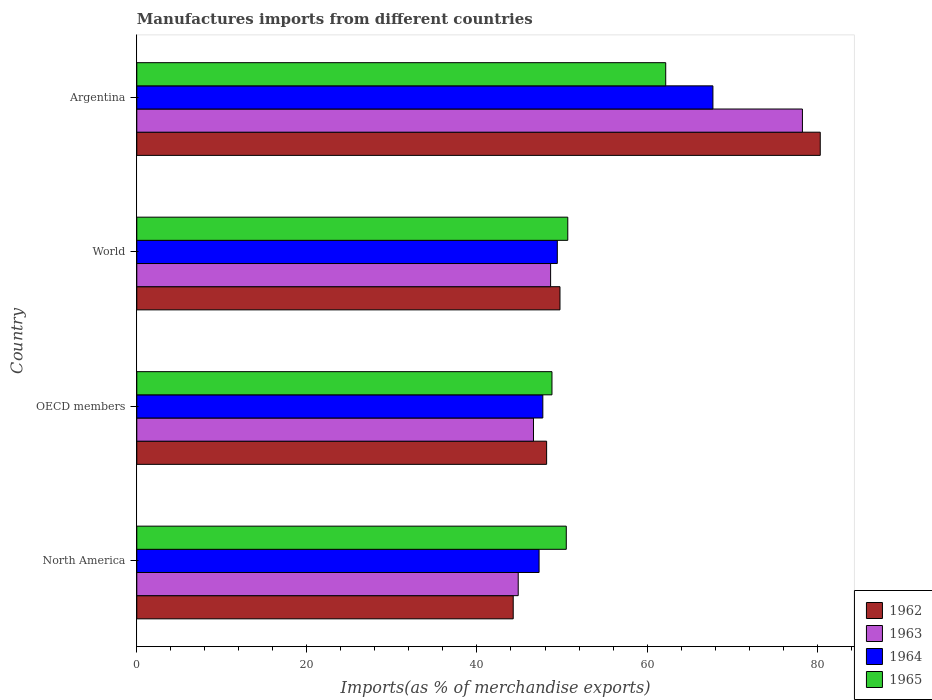How many groups of bars are there?
Provide a succinct answer. 4. Are the number of bars per tick equal to the number of legend labels?
Your answer should be very brief. Yes. Are the number of bars on each tick of the Y-axis equal?
Provide a succinct answer. Yes. What is the label of the 1st group of bars from the top?
Offer a very short reply. Argentina. In how many cases, is the number of bars for a given country not equal to the number of legend labels?
Your answer should be very brief. 0. What is the percentage of imports to different countries in 1964 in OECD members?
Give a very brief answer. 47.75. Across all countries, what is the maximum percentage of imports to different countries in 1963?
Your answer should be compact. 78.27. Across all countries, what is the minimum percentage of imports to different countries in 1963?
Ensure brevity in your answer.  44.85. In which country was the percentage of imports to different countries in 1962 maximum?
Offer a terse response. Argentina. What is the total percentage of imports to different countries in 1964 in the graph?
Keep it short and to the point. 212.24. What is the difference between the percentage of imports to different countries in 1962 in North America and that in OECD members?
Ensure brevity in your answer.  -3.93. What is the difference between the percentage of imports to different countries in 1963 in North America and the percentage of imports to different countries in 1964 in World?
Your response must be concise. -4.6. What is the average percentage of imports to different countries in 1962 per country?
Offer a very short reply. 55.65. What is the difference between the percentage of imports to different countries in 1964 and percentage of imports to different countries in 1965 in Argentina?
Ensure brevity in your answer.  5.55. What is the ratio of the percentage of imports to different countries in 1964 in North America to that in World?
Make the answer very short. 0.96. Is the percentage of imports to different countries in 1964 in North America less than that in World?
Provide a succinct answer. Yes. Is the difference between the percentage of imports to different countries in 1964 in OECD members and World greater than the difference between the percentage of imports to different countries in 1965 in OECD members and World?
Offer a very short reply. Yes. What is the difference between the highest and the second highest percentage of imports to different countries in 1965?
Keep it short and to the point. 11.52. What is the difference between the highest and the lowest percentage of imports to different countries in 1964?
Your response must be concise. 20.44. In how many countries, is the percentage of imports to different countries in 1965 greater than the average percentage of imports to different countries in 1965 taken over all countries?
Offer a very short reply. 1. Is the sum of the percentage of imports to different countries in 1963 in North America and World greater than the maximum percentage of imports to different countries in 1965 across all countries?
Offer a terse response. Yes. What does the 3rd bar from the bottom in Argentina represents?
Your answer should be very brief. 1964. How many bars are there?
Offer a very short reply. 16. How many countries are there in the graph?
Your answer should be compact. 4. What is the difference between two consecutive major ticks on the X-axis?
Your answer should be compact. 20. How are the legend labels stacked?
Offer a terse response. Vertical. What is the title of the graph?
Offer a terse response. Manufactures imports from different countries. What is the label or title of the X-axis?
Give a very brief answer. Imports(as % of merchandise exports). What is the label or title of the Y-axis?
Your response must be concise. Country. What is the Imports(as % of merchandise exports) in 1962 in North America?
Make the answer very short. 44.26. What is the Imports(as % of merchandise exports) of 1963 in North America?
Your answer should be compact. 44.85. What is the Imports(as % of merchandise exports) in 1964 in North America?
Make the answer very short. 47.3. What is the Imports(as % of merchandise exports) in 1965 in North America?
Your response must be concise. 50.5. What is the Imports(as % of merchandise exports) in 1962 in OECD members?
Your answer should be very brief. 48.19. What is the Imports(as % of merchandise exports) of 1963 in OECD members?
Offer a terse response. 46.65. What is the Imports(as % of merchandise exports) in 1964 in OECD members?
Ensure brevity in your answer.  47.75. What is the Imports(as % of merchandise exports) of 1965 in OECD members?
Offer a terse response. 48.82. What is the Imports(as % of merchandise exports) in 1962 in World?
Provide a short and direct response. 49.76. What is the Imports(as % of merchandise exports) in 1963 in World?
Give a very brief answer. 48.66. What is the Imports(as % of merchandise exports) of 1964 in World?
Your response must be concise. 49.45. What is the Imports(as % of merchandise exports) of 1965 in World?
Your answer should be very brief. 50.68. What is the Imports(as % of merchandise exports) of 1962 in Argentina?
Your answer should be very brief. 80.37. What is the Imports(as % of merchandise exports) in 1963 in Argentina?
Provide a succinct answer. 78.27. What is the Imports(as % of merchandise exports) of 1964 in Argentina?
Make the answer very short. 67.75. What is the Imports(as % of merchandise exports) of 1965 in Argentina?
Provide a short and direct response. 62.19. Across all countries, what is the maximum Imports(as % of merchandise exports) in 1962?
Provide a succinct answer. 80.37. Across all countries, what is the maximum Imports(as % of merchandise exports) in 1963?
Keep it short and to the point. 78.27. Across all countries, what is the maximum Imports(as % of merchandise exports) of 1964?
Provide a short and direct response. 67.75. Across all countries, what is the maximum Imports(as % of merchandise exports) in 1965?
Your answer should be compact. 62.19. Across all countries, what is the minimum Imports(as % of merchandise exports) in 1962?
Offer a terse response. 44.26. Across all countries, what is the minimum Imports(as % of merchandise exports) of 1963?
Offer a terse response. 44.85. Across all countries, what is the minimum Imports(as % of merchandise exports) of 1964?
Keep it short and to the point. 47.3. Across all countries, what is the minimum Imports(as % of merchandise exports) of 1965?
Your response must be concise. 48.82. What is the total Imports(as % of merchandise exports) in 1962 in the graph?
Provide a succinct answer. 222.58. What is the total Imports(as % of merchandise exports) of 1963 in the graph?
Ensure brevity in your answer.  218.43. What is the total Imports(as % of merchandise exports) of 1964 in the graph?
Give a very brief answer. 212.24. What is the total Imports(as % of merchandise exports) in 1965 in the graph?
Your answer should be compact. 212.2. What is the difference between the Imports(as % of merchandise exports) of 1962 in North America and that in OECD members?
Make the answer very short. -3.93. What is the difference between the Imports(as % of merchandise exports) of 1963 in North America and that in OECD members?
Provide a short and direct response. -1.8. What is the difference between the Imports(as % of merchandise exports) in 1964 in North America and that in OECD members?
Give a very brief answer. -0.44. What is the difference between the Imports(as % of merchandise exports) in 1965 in North America and that in OECD members?
Make the answer very short. 1.68. What is the difference between the Imports(as % of merchandise exports) of 1962 in North America and that in World?
Offer a terse response. -5.5. What is the difference between the Imports(as % of merchandise exports) in 1963 in North America and that in World?
Your answer should be very brief. -3.81. What is the difference between the Imports(as % of merchandise exports) in 1964 in North America and that in World?
Your answer should be very brief. -2.14. What is the difference between the Imports(as % of merchandise exports) in 1965 in North America and that in World?
Give a very brief answer. -0.18. What is the difference between the Imports(as % of merchandise exports) of 1962 in North America and that in Argentina?
Ensure brevity in your answer.  -36.1. What is the difference between the Imports(as % of merchandise exports) in 1963 in North America and that in Argentina?
Give a very brief answer. -33.42. What is the difference between the Imports(as % of merchandise exports) in 1964 in North America and that in Argentina?
Your response must be concise. -20.44. What is the difference between the Imports(as % of merchandise exports) in 1965 in North America and that in Argentina?
Give a very brief answer. -11.69. What is the difference between the Imports(as % of merchandise exports) of 1962 in OECD members and that in World?
Your answer should be very brief. -1.57. What is the difference between the Imports(as % of merchandise exports) in 1963 in OECD members and that in World?
Give a very brief answer. -2.01. What is the difference between the Imports(as % of merchandise exports) of 1964 in OECD members and that in World?
Your response must be concise. -1.7. What is the difference between the Imports(as % of merchandise exports) of 1965 in OECD members and that in World?
Provide a short and direct response. -1.86. What is the difference between the Imports(as % of merchandise exports) of 1962 in OECD members and that in Argentina?
Your response must be concise. -32.17. What is the difference between the Imports(as % of merchandise exports) in 1963 in OECD members and that in Argentina?
Your response must be concise. -31.62. What is the difference between the Imports(as % of merchandise exports) in 1964 in OECD members and that in Argentina?
Make the answer very short. -20. What is the difference between the Imports(as % of merchandise exports) of 1965 in OECD members and that in Argentina?
Provide a succinct answer. -13.38. What is the difference between the Imports(as % of merchandise exports) in 1962 in World and that in Argentina?
Offer a very short reply. -30.61. What is the difference between the Imports(as % of merchandise exports) in 1963 in World and that in Argentina?
Your answer should be very brief. -29.61. What is the difference between the Imports(as % of merchandise exports) of 1964 in World and that in Argentina?
Provide a short and direct response. -18.3. What is the difference between the Imports(as % of merchandise exports) of 1965 in World and that in Argentina?
Provide a short and direct response. -11.52. What is the difference between the Imports(as % of merchandise exports) of 1962 in North America and the Imports(as % of merchandise exports) of 1963 in OECD members?
Your answer should be very brief. -2.38. What is the difference between the Imports(as % of merchandise exports) in 1962 in North America and the Imports(as % of merchandise exports) in 1964 in OECD members?
Offer a terse response. -3.48. What is the difference between the Imports(as % of merchandise exports) in 1962 in North America and the Imports(as % of merchandise exports) in 1965 in OECD members?
Your answer should be very brief. -4.56. What is the difference between the Imports(as % of merchandise exports) in 1963 in North America and the Imports(as % of merchandise exports) in 1964 in OECD members?
Offer a very short reply. -2.89. What is the difference between the Imports(as % of merchandise exports) in 1963 in North America and the Imports(as % of merchandise exports) in 1965 in OECD members?
Provide a succinct answer. -3.97. What is the difference between the Imports(as % of merchandise exports) of 1964 in North America and the Imports(as % of merchandise exports) of 1965 in OECD members?
Offer a very short reply. -1.52. What is the difference between the Imports(as % of merchandise exports) of 1962 in North America and the Imports(as % of merchandise exports) of 1963 in World?
Offer a terse response. -4.4. What is the difference between the Imports(as % of merchandise exports) of 1962 in North America and the Imports(as % of merchandise exports) of 1964 in World?
Make the answer very short. -5.19. What is the difference between the Imports(as % of merchandise exports) of 1962 in North America and the Imports(as % of merchandise exports) of 1965 in World?
Offer a very short reply. -6.42. What is the difference between the Imports(as % of merchandise exports) in 1963 in North America and the Imports(as % of merchandise exports) in 1964 in World?
Provide a short and direct response. -4.6. What is the difference between the Imports(as % of merchandise exports) in 1963 in North America and the Imports(as % of merchandise exports) in 1965 in World?
Your answer should be very brief. -5.83. What is the difference between the Imports(as % of merchandise exports) of 1964 in North America and the Imports(as % of merchandise exports) of 1965 in World?
Provide a short and direct response. -3.37. What is the difference between the Imports(as % of merchandise exports) of 1962 in North America and the Imports(as % of merchandise exports) of 1963 in Argentina?
Your response must be concise. -34.01. What is the difference between the Imports(as % of merchandise exports) of 1962 in North America and the Imports(as % of merchandise exports) of 1964 in Argentina?
Your response must be concise. -23.48. What is the difference between the Imports(as % of merchandise exports) in 1962 in North America and the Imports(as % of merchandise exports) in 1965 in Argentina?
Provide a succinct answer. -17.93. What is the difference between the Imports(as % of merchandise exports) in 1963 in North America and the Imports(as % of merchandise exports) in 1964 in Argentina?
Your answer should be compact. -22.89. What is the difference between the Imports(as % of merchandise exports) in 1963 in North America and the Imports(as % of merchandise exports) in 1965 in Argentina?
Your answer should be very brief. -17.34. What is the difference between the Imports(as % of merchandise exports) of 1964 in North America and the Imports(as % of merchandise exports) of 1965 in Argentina?
Your response must be concise. -14.89. What is the difference between the Imports(as % of merchandise exports) of 1962 in OECD members and the Imports(as % of merchandise exports) of 1963 in World?
Offer a terse response. -0.47. What is the difference between the Imports(as % of merchandise exports) of 1962 in OECD members and the Imports(as % of merchandise exports) of 1964 in World?
Provide a short and direct response. -1.26. What is the difference between the Imports(as % of merchandise exports) of 1962 in OECD members and the Imports(as % of merchandise exports) of 1965 in World?
Provide a succinct answer. -2.49. What is the difference between the Imports(as % of merchandise exports) of 1963 in OECD members and the Imports(as % of merchandise exports) of 1964 in World?
Provide a short and direct response. -2.8. What is the difference between the Imports(as % of merchandise exports) in 1963 in OECD members and the Imports(as % of merchandise exports) in 1965 in World?
Make the answer very short. -4.03. What is the difference between the Imports(as % of merchandise exports) in 1964 in OECD members and the Imports(as % of merchandise exports) in 1965 in World?
Offer a terse response. -2.93. What is the difference between the Imports(as % of merchandise exports) of 1962 in OECD members and the Imports(as % of merchandise exports) of 1963 in Argentina?
Ensure brevity in your answer.  -30.08. What is the difference between the Imports(as % of merchandise exports) in 1962 in OECD members and the Imports(as % of merchandise exports) in 1964 in Argentina?
Provide a short and direct response. -19.55. What is the difference between the Imports(as % of merchandise exports) in 1962 in OECD members and the Imports(as % of merchandise exports) in 1965 in Argentina?
Your answer should be very brief. -14. What is the difference between the Imports(as % of merchandise exports) of 1963 in OECD members and the Imports(as % of merchandise exports) of 1964 in Argentina?
Provide a succinct answer. -21.1. What is the difference between the Imports(as % of merchandise exports) of 1963 in OECD members and the Imports(as % of merchandise exports) of 1965 in Argentina?
Offer a very short reply. -15.55. What is the difference between the Imports(as % of merchandise exports) of 1964 in OECD members and the Imports(as % of merchandise exports) of 1965 in Argentina?
Your answer should be compact. -14.45. What is the difference between the Imports(as % of merchandise exports) in 1962 in World and the Imports(as % of merchandise exports) in 1963 in Argentina?
Your answer should be very brief. -28.51. What is the difference between the Imports(as % of merchandise exports) of 1962 in World and the Imports(as % of merchandise exports) of 1964 in Argentina?
Offer a terse response. -17.98. What is the difference between the Imports(as % of merchandise exports) of 1962 in World and the Imports(as % of merchandise exports) of 1965 in Argentina?
Provide a short and direct response. -12.43. What is the difference between the Imports(as % of merchandise exports) in 1963 in World and the Imports(as % of merchandise exports) in 1964 in Argentina?
Keep it short and to the point. -19.09. What is the difference between the Imports(as % of merchandise exports) of 1963 in World and the Imports(as % of merchandise exports) of 1965 in Argentina?
Offer a terse response. -13.54. What is the difference between the Imports(as % of merchandise exports) in 1964 in World and the Imports(as % of merchandise exports) in 1965 in Argentina?
Make the answer very short. -12.75. What is the average Imports(as % of merchandise exports) of 1962 per country?
Offer a very short reply. 55.65. What is the average Imports(as % of merchandise exports) of 1963 per country?
Provide a short and direct response. 54.61. What is the average Imports(as % of merchandise exports) in 1964 per country?
Make the answer very short. 53.06. What is the average Imports(as % of merchandise exports) of 1965 per country?
Offer a very short reply. 53.05. What is the difference between the Imports(as % of merchandise exports) of 1962 and Imports(as % of merchandise exports) of 1963 in North America?
Offer a very short reply. -0.59. What is the difference between the Imports(as % of merchandise exports) of 1962 and Imports(as % of merchandise exports) of 1964 in North America?
Offer a terse response. -3.04. What is the difference between the Imports(as % of merchandise exports) of 1962 and Imports(as % of merchandise exports) of 1965 in North America?
Offer a very short reply. -6.24. What is the difference between the Imports(as % of merchandise exports) in 1963 and Imports(as % of merchandise exports) in 1964 in North America?
Keep it short and to the point. -2.45. What is the difference between the Imports(as % of merchandise exports) in 1963 and Imports(as % of merchandise exports) in 1965 in North America?
Your answer should be very brief. -5.65. What is the difference between the Imports(as % of merchandise exports) of 1964 and Imports(as % of merchandise exports) of 1965 in North America?
Provide a short and direct response. -3.2. What is the difference between the Imports(as % of merchandise exports) in 1962 and Imports(as % of merchandise exports) in 1963 in OECD members?
Offer a very short reply. 1.55. What is the difference between the Imports(as % of merchandise exports) of 1962 and Imports(as % of merchandise exports) of 1964 in OECD members?
Offer a very short reply. 0.45. What is the difference between the Imports(as % of merchandise exports) in 1962 and Imports(as % of merchandise exports) in 1965 in OECD members?
Give a very brief answer. -0.63. What is the difference between the Imports(as % of merchandise exports) in 1963 and Imports(as % of merchandise exports) in 1964 in OECD members?
Make the answer very short. -1.1. What is the difference between the Imports(as % of merchandise exports) in 1963 and Imports(as % of merchandise exports) in 1965 in OECD members?
Make the answer very short. -2.17. What is the difference between the Imports(as % of merchandise exports) in 1964 and Imports(as % of merchandise exports) in 1965 in OECD members?
Offer a very short reply. -1.07. What is the difference between the Imports(as % of merchandise exports) in 1962 and Imports(as % of merchandise exports) in 1963 in World?
Your answer should be compact. 1.1. What is the difference between the Imports(as % of merchandise exports) of 1962 and Imports(as % of merchandise exports) of 1964 in World?
Make the answer very short. 0.31. What is the difference between the Imports(as % of merchandise exports) in 1962 and Imports(as % of merchandise exports) in 1965 in World?
Give a very brief answer. -0.92. What is the difference between the Imports(as % of merchandise exports) of 1963 and Imports(as % of merchandise exports) of 1964 in World?
Ensure brevity in your answer.  -0.79. What is the difference between the Imports(as % of merchandise exports) of 1963 and Imports(as % of merchandise exports) of 1965 in World?
Your answer should be very brief. -2.02. What is the difference between the Imports(as % of merchandise exports) of 1964 and Imports(as % of merchandise exports) of 1965 in World?
Your answer should be compact. -1.23. What is the difference between the Imports(as % of merchandise exports) in 1962 and Imports(as % of merchandise exports) in 1963 in Argentina?
Your answer should be compact. 2.1. What is the difference between the Imports(as % of merchandise exports) of 1962 and Imports(as % of merchandise exports) of 1964 in Argentina?
Your answer should be compact. 12.62. What is the difference between the Imports(as % of merchandise exports) of 1962 and Imports(as % of merchandise exports) of 1965 in Argentina?
Make the answer very short. 18.17. What is the difference between the Imports(as % of merchandise exports) of 1963 and Imports(as % of merchandise exports) of 1964 in Argentina?
Your response must be concise. 10.52. What is the difference between the Imports(as % of merchandise exports) in 1963 and Imports(as % of merchandise exports) in 1965 in Argentina?
Offer a very short reply. 16.08. What is the difference between the Imports(as % of merchandise exports) of 1964 and Imports(as % of merchandise exports) of 1965 in Argentina?
Provide a succinct answer. 5.55. What is the ratio of the Imports(as % of merchandise exports) of 1962 in North America to that in OECD members?
Give a very brief answer. 0.92. What is the ratio of the Imports(as % of merchandise exports) in 1963 in North America to that in OECD members?
Provide a succinct answer. 0.96. What is the ratio of the Imports(as % of merchandise exports) of 1965 in North America to that in OECD members?
Your response must be concise. 1.03. What is the ratio of the Imports(as % of merchandise exports) of 1962 in North America to that in World?
Give a very brief answer. 0.89. What is the ratio of the Imports(as % of merchandise exports) in 1963 in North America to that in World?
Your answer should be very brief. 0.92. What is the ratio of the Imports(as % of merchandise exports) in 1964 in North America to that in World?
Your answer should be compact. 0.96. What is the ratio of the Imports(as % of merchandise exports) of 1965 in North America to that in World?
Provide a short and direct response. 1. What is the ratio of the Imports(as % of merchandise exports) in 1962 in North America to that in Argentina?
Your answer should be compact. 0.55. What is the ratio of the Imports(as % of merchandise exports) in 1963 in North America to that in Argentina?
Provide a succinct answer. 0.57. What is the ratio of the Imports(as % of merchandise exports) in 1964 in North America to that in Argentina?
Provide a succinct answer. 0.7. What is the ratio of the Imports(as % of merchandise exports) of 1965 in North America to that in Argentina?
Make the answer very short. 0.81. What is the ratio of the Imports(as % of merchandise exports) of 1962 in OECD members to that in World?
Your response must be concise. 0.97. What is the ratio of the Imports(as % of merchandise exports) in 1963 in OECD members to that in World?
Offer a terse response. 0.96. What is the ratio of the Imports(as % of merchandise exports) of 1964 in OECD members to that in World?
Your response must be concise. 0.97. What is the ratio of the Imports(as % of merchandise exports) of 1965 in OECD members to that in World?
Your answer should be very brief. 0.96. What is the ratio of the Imports(as % of merchandise exports) in 1962 in OECD members to that in Argentina?
Offer a terse response. 0.6. What is the ratio of the Imports(as % of merchandise exports) in 1963 in OECD members to that in Argentina?
Offer a very short reply. 0.6. What is the ratio of the Imports(as % of merchandise exports) in 1964 in OECD members to that in Argentina?
Provide a short and direct response. 0.7. What is the ratio of the Imports(as % of merchandise exports) of 1965 in OECD members to that in Argentina?
Keep it short and to the point. 0.78. What is the ratio of the Imports(as % of merchandise exports) of 1962 in World to that in Argentina?
Give a very brief answer. 0.62. What is the ratio of the Imports(as % of merchandise exports) of 1963 in World to that in Argentina?
Give a very brief answer. 0.62. What is the ratio of the Imports(as % of merchandise exports) of 1964 in World to that in Argentina?
Keep it short and to the point. 0.73. What is the ratio of the Imports(as % of merchandise exports) in 1965 in World to that in Argentina?
Offer a terse response. 0.81. What is the difference between the highest and the second highest Imports(as % of merchandise exports) in 1962?
Make the answer very short. 30.61. What is the difference between the highest and the second highest Imports(as % of merchandise exports) of 1963?
Your answer should be very brief. 29.61. What is the difference between the highest and the second highest Imports(as % of merchandise exports) in 1964?
Your response must be concise. 18.3. What is the difference between the highest and the second highest Imports(as % of merchandise exports) in 1965?
Provide a succinct answer. 11.52. What is the difference between the highest and the lowest Imports(as % of merchandise exports) in 1962?
Your answer should be compact. 36.1. What is the difference between the highest and the lowest Imports(as % of merchandise exports) in 1963?
Offer a terse response. 33.42. What is the difference between the highest and the lowest Imports(as % of merchandise exports) in 1964?
Make the answer very short. 20.44. What is the difference between the highest and the lowest Imports(as % of merchandise exports) in 1965?
Your answer should be very brief. 13.38. 